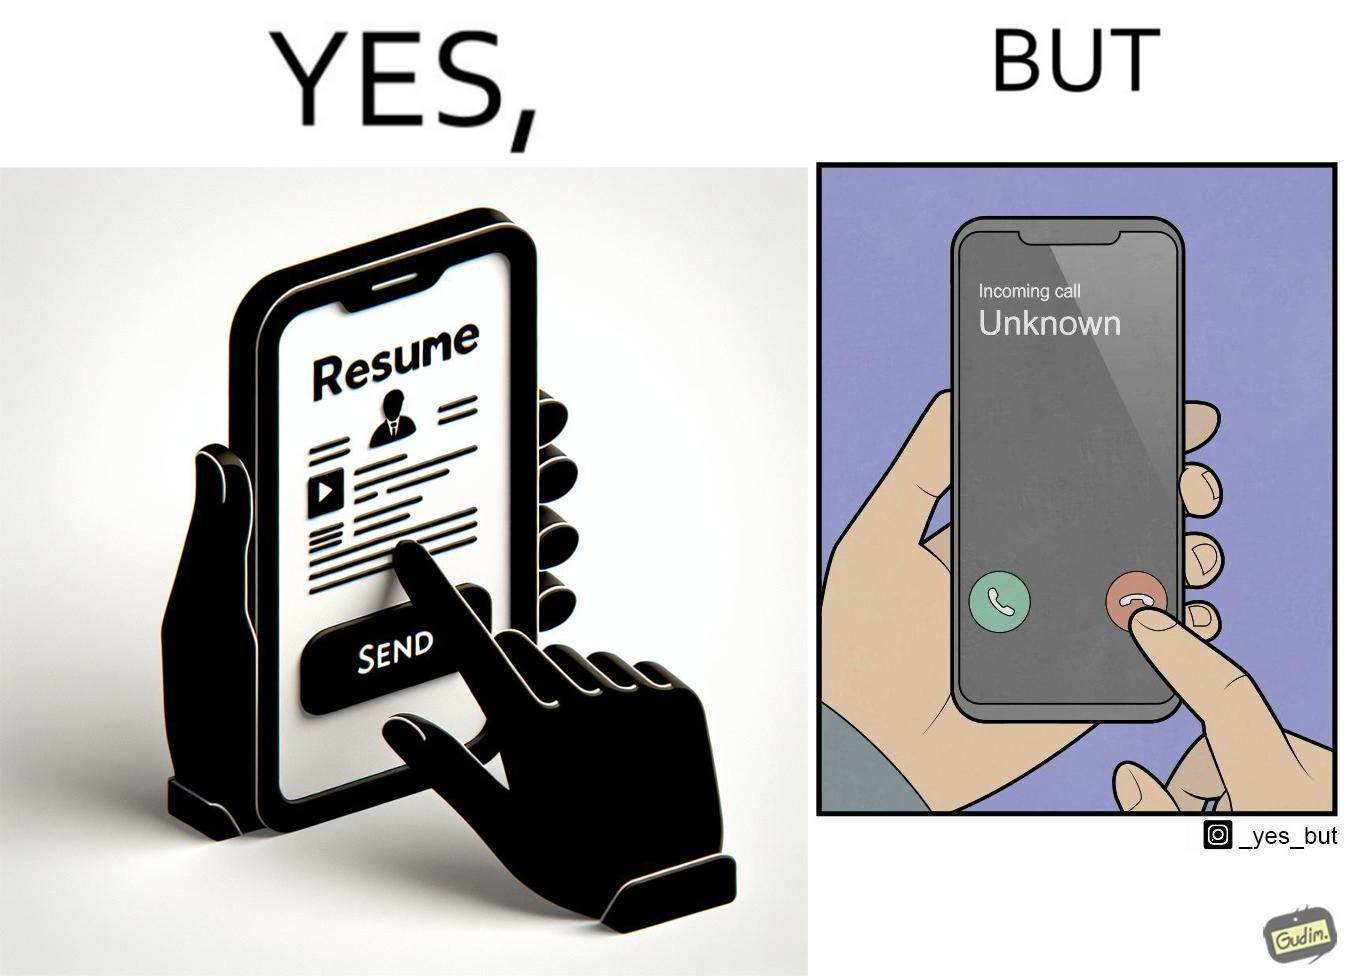Compare the left and right sides of this image. In the left part of the image: a mobile screen with resume asking the user whether to send button In the right part of the image: a mobile screen with an incoming call from unknown which the person might be rejecting 